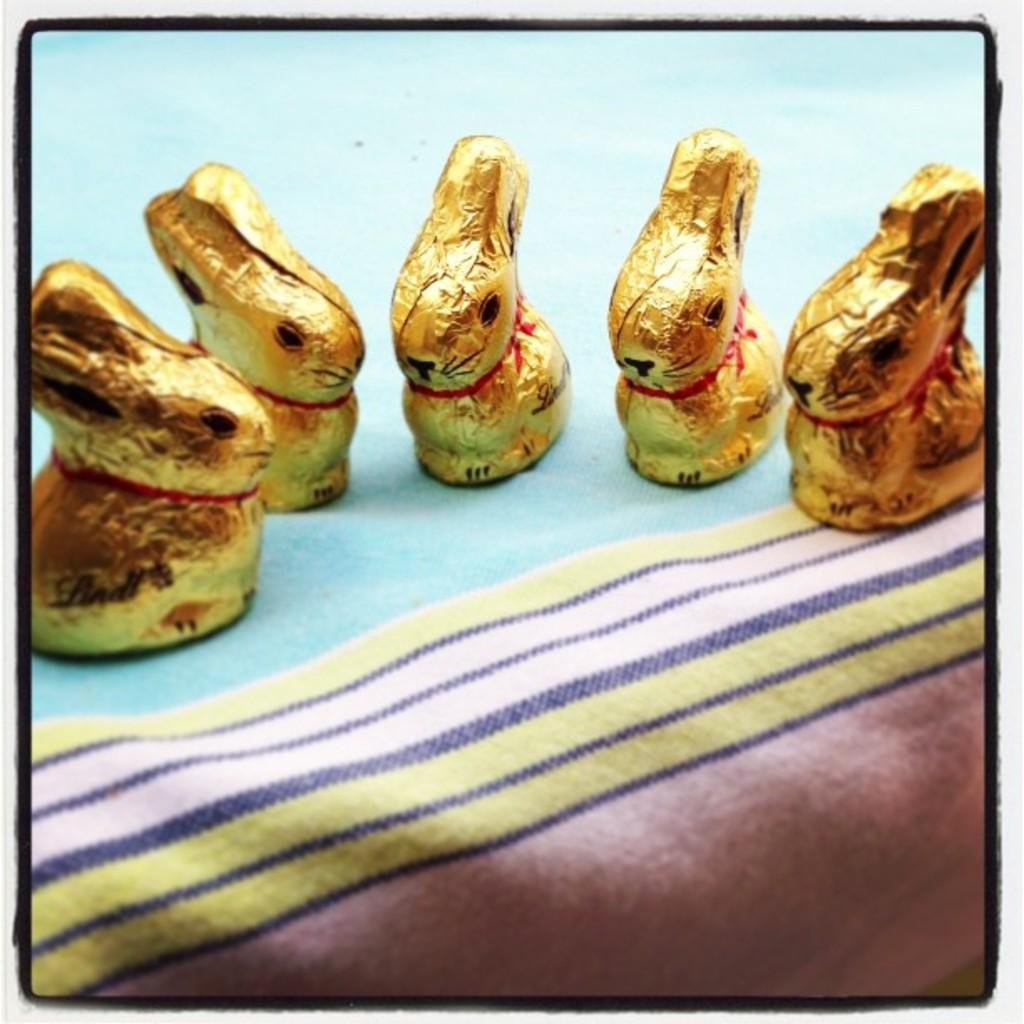What is the main object in the image? There is a cloth in the image. What colors can be seen on the cloth? The cloth has blue, yellow, white, and pink colors. Are there any specific shapes or designs on the cloth? Yes, there are gold-colored objects on the cloth. What shape are the gold-colored objects? The gold-colored objects are in the shape of a rabbit. What type of advertisement is being displayed on the cloth? There is no advertisement present on the cloth; it is a cloth with gold-colored rabbit shapes. How many bananas are visible on the cloth? There are no bananas visible on the cloth; it features gold-colored rabbit shapes. 